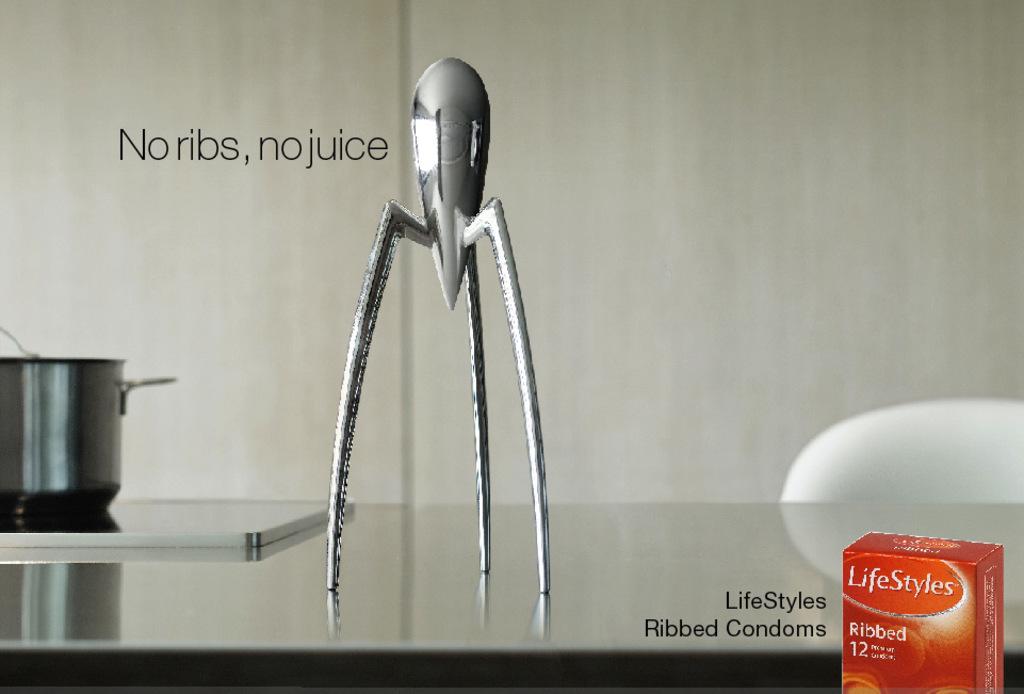What is the product in the advertisement?
Your answer should be very brief. Lifestyles ribbed condoms. No ribes, no what?
Provide a short and direct response. Juice. 